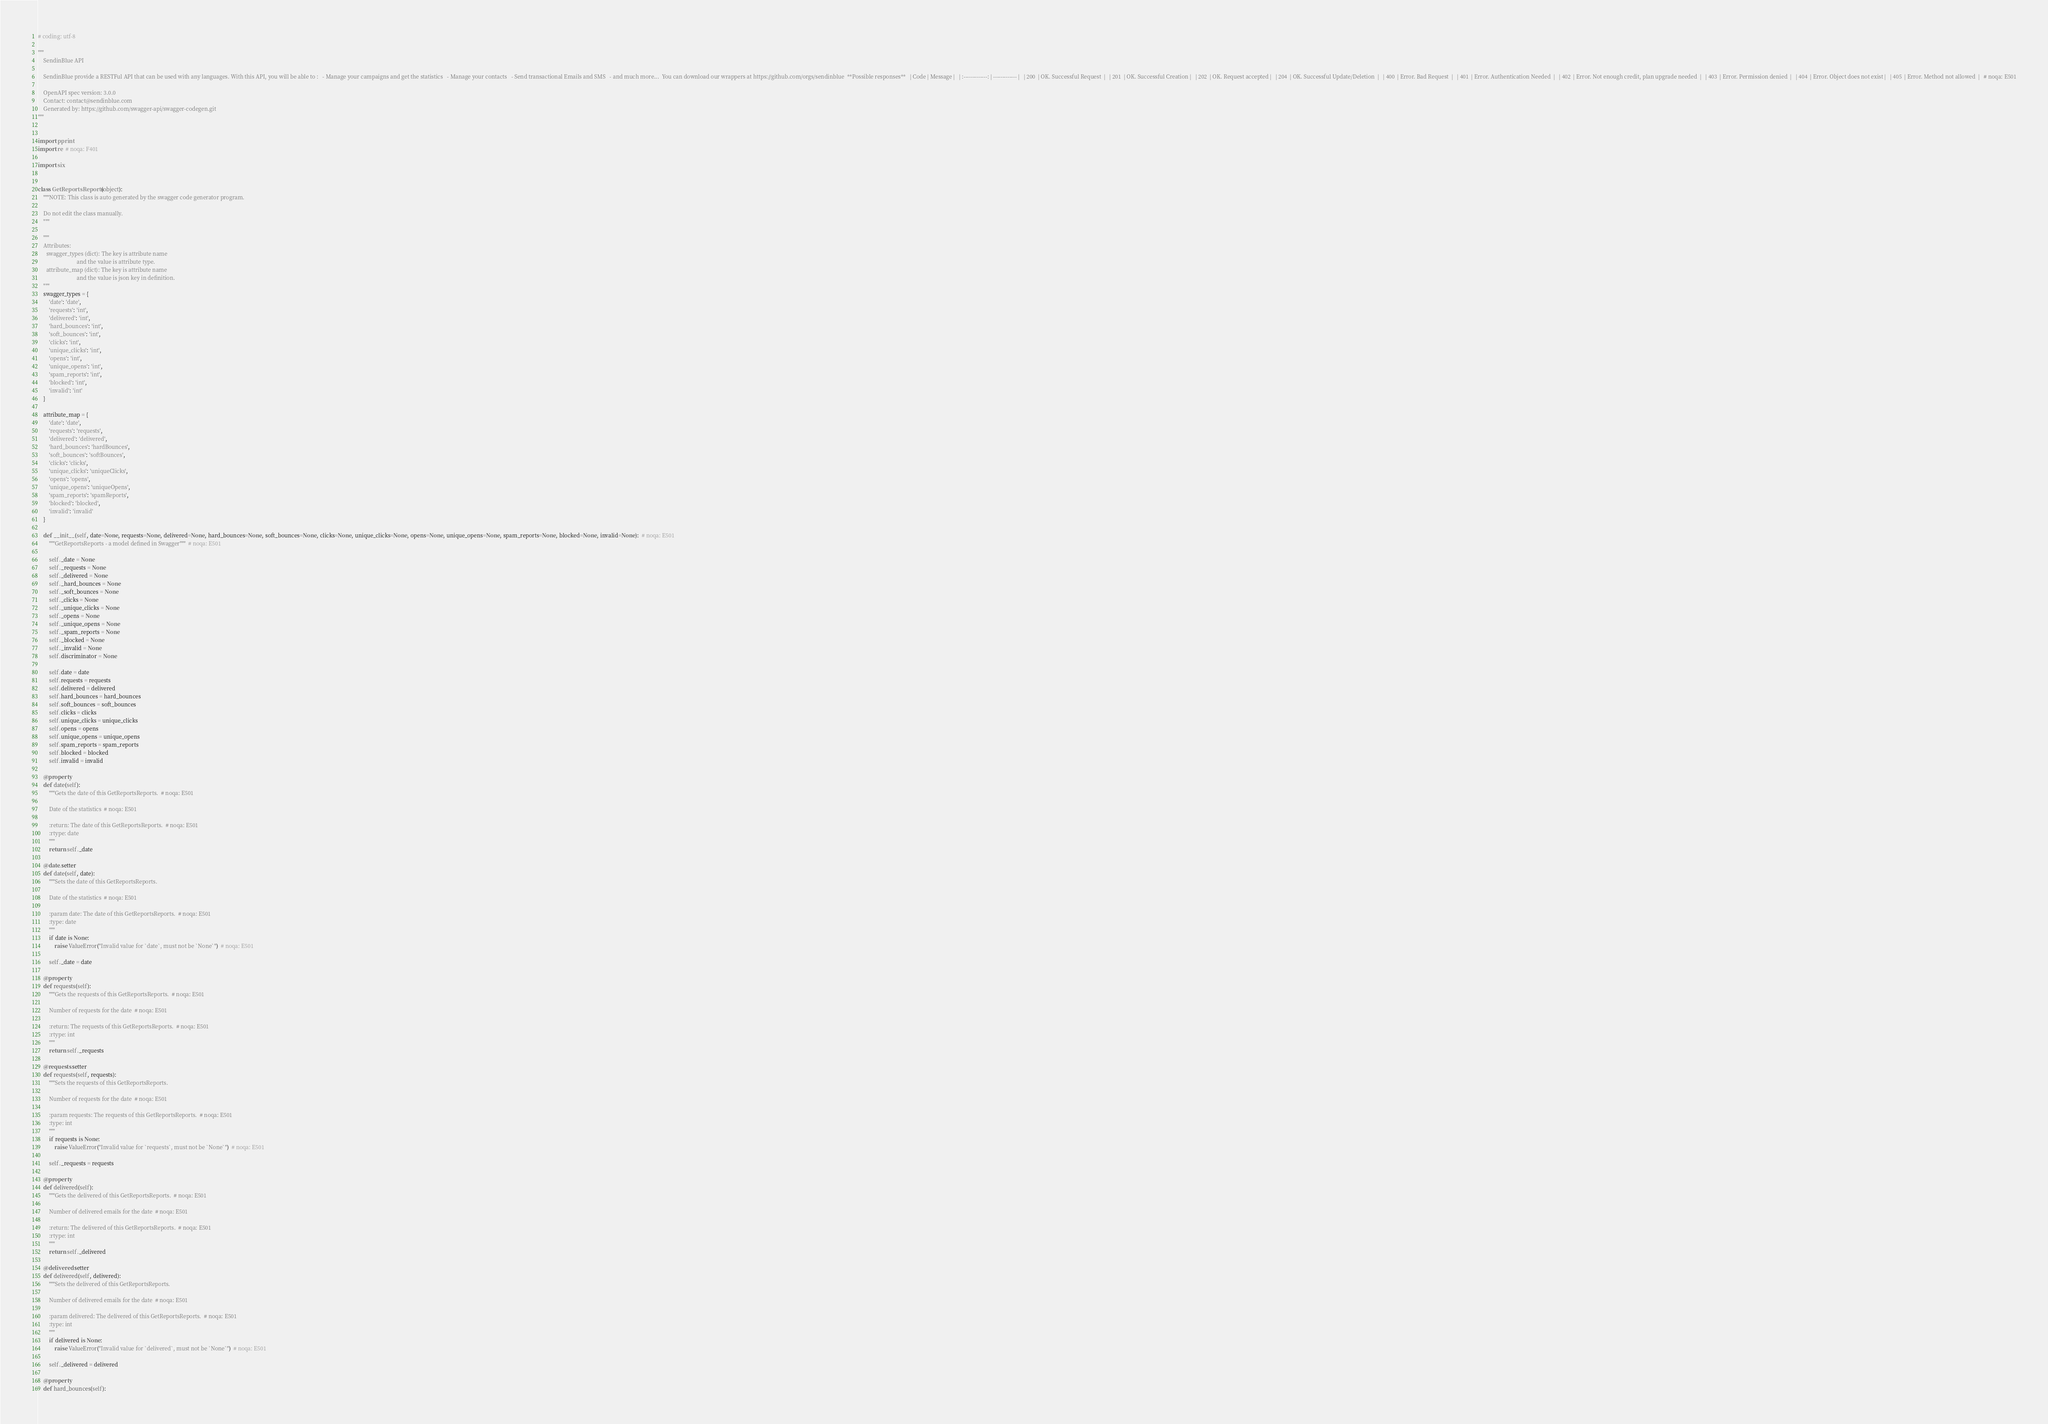<code> <loc_0><loc_0><loc_500><loc_500><_Python_># coding: utf-8

"""
    SendinBlue API

    SendinBlue provide a RESTFul API that can be used with any languages. With this API, you will be able to :   - Manage your campaigns and get the statistics   - Manage your contacts   - Send transactional Emails and SMS   - and much more...  You can download our wrappers at https://github.com/orgs/sendinblue  **Possible responses**   | Code | Message |   | :-------------: | ------------- |   | 200  | OK. Successful Request  |   | 201  | OK. Successful Creation |   | 202  | OK. Request accepted |   | 204  | OK. Successful Update/Deletion  |   | 400  | Error. Bad Request  |   | 401  | Error. Authentication Needed  |   | 402  | Error. Not enough credit, plan upgrade needed  |   | 403  | Error. Permission denied  |   | 404  | Error. Object does not exist |   | 405  | Error. Method not allowed  |   # noqa: E501

    OpenAPI spec version: 3.0.0
    Contact: contact@sendinblue.com
    Generated by: https://github.com/swagger-api/swagger-codegen.git
"""


import pprint
import re  # noqa: F401

import six


class GetReportsReports(object):
    """NOTE: This class is auto generated by the swagger code generator program.

    Do not edit the class manually.
    """

    """
    Attributes:
      swagger_types (dict): The key is attribute name
                            and the value is attribute type.
      attribute_map (dict): The key is attribute name
                            and the value is json key in definition.
    """
    swagger_types = {
        'date': 'date',
        'requests': 'int',
        'delivered': 'int',
        'hard_bounces': 'int',
        'soft_bounces': 'int',
        'clicks': 'int',
        'unique_clicks': 'int',
        'opens': 'int',
        'unique_opens': 'int',
        'spam_reports': 'int',
        'blocked': 'int',
        'invalid': 'int'
    }

    attribute_map = {
        'date': 'date',
        'requests': 'requests',
        'delivered': 'delivered',
        'hard_bounces': 'hardBounces',
        'soft_bounces': 'softBounces',
        'clicks': 'clicks',
        'unique_clicks': 'uniqueClicks',
        'opens': 'opens',
        'unique_opens': 'uniqueOpens',
        'spam_reports': 'spamReports',
        'blocked': 'blocked',
        'invalid': 'invalid'
    }

    def __init__(self, date=None, requests=None, delivered=None, hard_bounces=None, soft_bounces=None, clicks=None, unique_clicks=None, opens=None, unique_opens=None, spam_reports=None, blocked=None, invalid=None):  # noqa: E501
        """GetReportsReports - a model defined in Swagger"""  # noqa: E501

        self._date = None
        self._requests = None
        self._delivered = None
        self._hard_bounces = None
        self._soft_bounces = None
        self._clicks = None
        self._unique_clicks = None
        self._opens = None
        self._unique_opens = None
        self._spam_reports = None
        self._blocked = None
        self._invalid = None
        self.discriminator = None

        self.date = date
        self.requests = requests
        self.delivered = delivered
        self.hard_bounces = hard_bounces
        self.soft_bounces = soft_bounces
        self.clicks = clicks
        self.unique_clicks = unique_clicks
        self.opens = opens
        self.unique_opens = unique_opens
        self.spam_reports = spam_reports
        self.blocked = blocked
        self.invalid = invalid

    @property
    def date(self):
        """Gets the date of this GetReportsReports.  # noqa: E501

        Date of the statistics  # noqa: E501

        :return: The date of this GetReportsReports.  # noqa: E501
        :rtype: date
        """
        return self._date

    @date.setter
    def date(self, date):
        """Sets the date of this GetReportsReports.

        Date of the statistics  # noqa: E501

        :param date: The date of this GetReportsReports.  # noqa: E501
        :type: date
        """
        if date is None:
            raise ValueError("Invalid value for `date`, must not be `None`")  # noqa: E501

        self._date = date

    @property
    def requests(self):
        """Gets the requests of this GetReportsReports.  # noqa: E501

        Number of requests for the date  # noqa: E501

        :return: The requests of this GetReportsReports.  # noqa: E501
        :rtype: int
        """
        return self._requests

    @requests.setter
    def requests(self, requests):
        """Sets the requests of this GetReportsReports.

        Number of requests for the date  # noqa: E501

        :param requests: The requests of this GetReportsReports.  # noqa: E501
        :type: int
        """
        if requests is None:
            raise ValueError("Invalid value for `requests`, must not be `None`")  # noqa: E501

        self._requests = requests

    @property
    def delivered(self):
        """Gets the delivered of this GetReportsReports.  # noqa: E501

        Number of delivered emails for the date  # noqa: E501

        :return: The delivered of this GetReportsReports.  # noqa: E501
        :rtype: int
        """
        return self._delivered

    @delivered.setter
    def delivered(self, delivered):
        """Sets the delivered of this GetReportsReports.

        Number of delivered emails for the date  # noqa: E501

        :param delivered: The delivered of this GetReportsReports.  # noqa: E501
        :type: int
        """
        if delivered is None:
            raise ValueError("Invalid value for `delivered`, must not be `None`")  # noqa: E501

        self._delivered = delivered

    @property
    def hard_bounces(self):</code> 